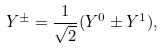Convert formula to latex. <formula><loc_0><loc_0><loc_500><loc_500>Y ^ { \pm } = \frac { 1 } { \sqrt { 2 } } ( Y ^ { 0 } \pm Y ^ { 1 } ) ,</formula> 